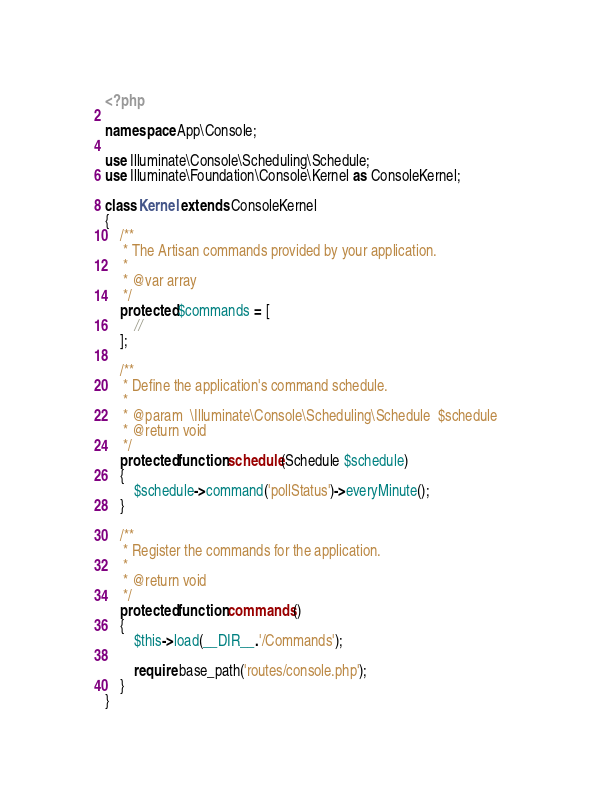Convert code to text. <code><loc_0><loc_0><loc_500><loc_500><_PHP_><?php

namespace App\Console;

use Illuminate\Console\Scheduling\Schedule;
use Illuminate\Foundation\Console\Kernel as ConsoleKernel;

class Kernel extends ConsoleKernel
{
    /**
     * The Artisan commands provided by your application.
     *
     * @var array
     */
    protected $commands = [
        //
    ];

    /**
     * Define the application's command schedule.
     *
     * @param  \Illuminate\Console\Scheduling\Schedule  $schedule
     * @return void
     */
    protected function schedule(Schedule $schedule)
    {
        $schedule->command('pollStatus')->everyMinute();
    }

    /**
     * Register the commands for the application.
     *
     * @return void
     */
    protected function commands()
    {
        $this->load(__DIR__.'/Commands');

        require base_path('routes/console.php');
    }
}
</code> 